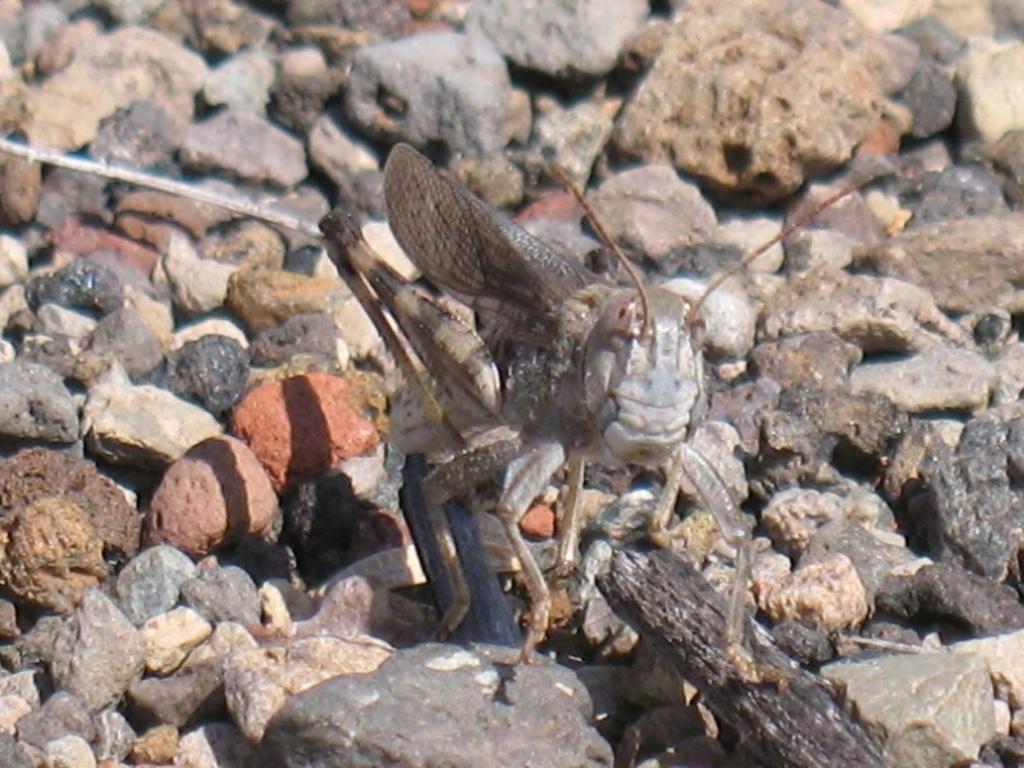Describe this image in one or two sentences. Here in this picture we can see a band wing grasshopper present on the ground and we can see stones present all over there. 